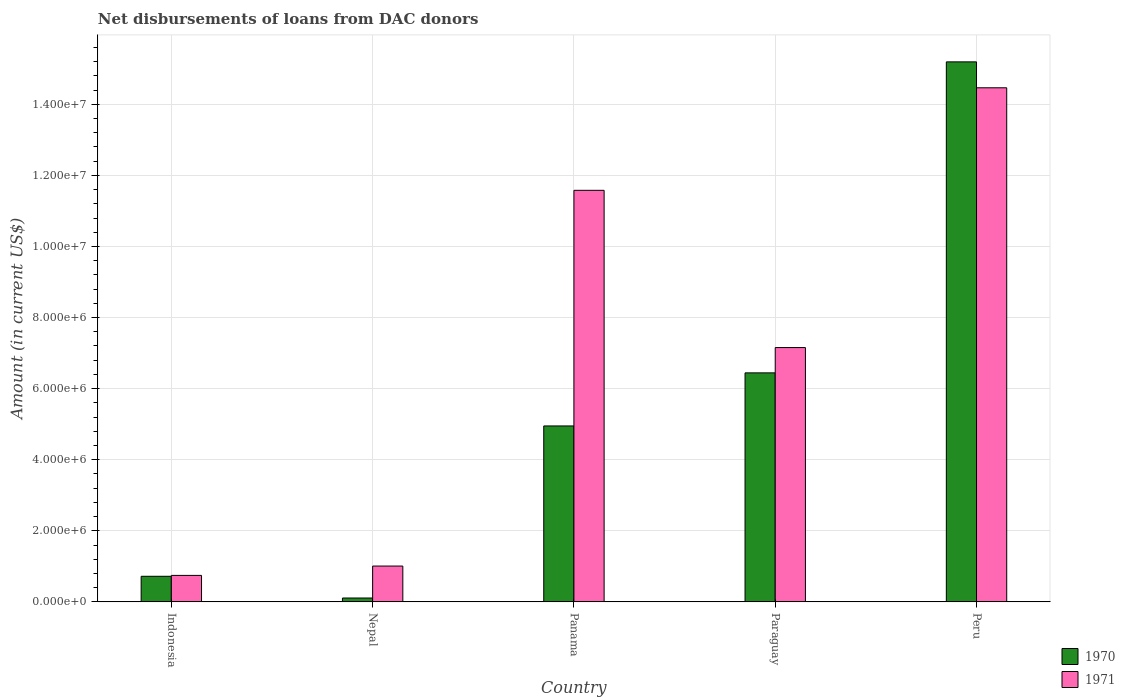How many different coloured bars are there?
Your response must be concise. 2. How many bars are there on the 1st tick from the left?
Your answer should be very brief. 2. How many bars are there on the 3rd tick from the right?
Your response must be concise. 2. What is the label of the 5th group of bars from the left?
Provide a succinct answer. Peru. What is the amount of loans disbursed in 1971 in Peru?
Your answer should be very brief. 1.45e+07. Across all countries, what is the maximum amount of loans disbursed in 1971?
Offer a terse response. 1.45e+07. Across all countries, what is the minimum amount of loans disbursed in 1970?
Your response must be concise. 1.09e+05. In which country was the amount of loans disbursed in 1971 maximum?
Make the answer very short. Peru. In which country was the amount of loans disbursed in 1970 minimum?
Keep it short and to the point. Nepal. What is the total amount of loans disbursed in 1970 in the graph?
Keep it short and to the point. 2.74e+07. What is the difference between the amount of loans disbursed in 1971 in Indonesia and that in Nepal?
Provide a succinct answer. -2.63e+05. What is the difference between the amount of loans disbursed in 1971 in Nepal and the amount of loans disbursed in 1970 in Paraguay?
Keep it short and to the point. -5.44e+06. What is the average amount of loans disbursed in 1970 per country?
Ensure brevity in your answer.  5.48e+06. What is the difference between the amount of loans disbursed of/in 1970 and amount of loans disbursed of/in 1971 in Paraguay?
Your answer should be compact. -7.12e+05. What is the ratio of the amount of loans disbursed in 1971 in Indonesia to that in Paraguay?
Your answer should be very brief. 0.1. Is the amount of loans disbursed in 1971 in Panama less than that in Paraguay?
Give a very brief answer. No. Is the difference between the amount of loans disbursed in 1970 in Nepal and Paraguay greater than the difference between the amount of loans disbursed in 1971 in Nepal and Paraguay?
Your response must be concise. No. What is the difference between the highest and the second highest amount of loans disbursed in 1970?
Provide a short and direct response. 1.02e+07. What is the difference between the highest and the lowest amount of loans disbursed in 1971?
Ensure brevity in your answer.  1.37e+07. In how many countries, is the amount of loans disbursed in 1971 greater than the average amount of loans disbursed in 1971 taken over all countries?
Offer a very short reply. 3. What does the 1st bar from the right in Nepal represents?
Offer a terse response. 1971. How many countries are there in the graph?
Make the answer very short. 5. Are the values on the major ticks of Y-axis written in scientific E-notation?
Your answer should be compact. Yes. Does the graph contain any zero values?
Provide a short and direct response. No. Does the graph contain grids?
Your response must be concise. Yes. Where does the legend appear in the graph?
Provide a succinct answer. Bottom right. How many legend labels are there?
Your answer should be very brief. 2. What is the title of the graph?
Your answer should be very brief. Net disbursements of loans from DAC donors. Does "2005" appear as one of the legend labels in the graph?
Offer a very short reply. No. What is the label or title of the X-axis?
Your answer should be very brief. Country. What is the label or title of the Y-axis?
Make the answer very short. Amount (in current US$). What is the Amount (in current US$) of 1970 in Indonesia?
Keep it short and to the point. 7.20e+05. What is the Amount (in current US$) of 1971 in Indonesia?
Your answer should be compact. 7.45e+05. What is the Amount (in current US$) of 1970 in Nepal?
Give a very brief answer. 1.09e+05. What is the Amount (in current US$) of 1971 in Nepal?
Make the answer very short. 1.01e+06. What is the Amount (in current US$) of 1970 in Panama?
Offer a terse response. 4.95e+06. What is the Amount (in current US$) in 1971 in Panama?
Offer a very short reply. 1.16e+07. What is the Amount (in current US$) in 1970 in Paraguay?
Offer a very short reply. 6.44e+06. What is the Amount (in current US$) of 1971 in Paraguay?
Make the answer very short. 7.16e+06. What is the Amount (in current US$) of 1970 in Peru?
Offer a very short reply. 1.52e+07. What is the Amount (in current US$) of 1971 in Peru?
Offer a very short reply. 1.45e+07. Across all countries, what is the maximum Amount (in current US$) of 1970?
Offer a terse response. 1.52e+07. Across all countries, what is the maximum Amount (in current US$) in 1971?
Your response must be concise. 1.45e+07. Across all countries, what is the minimum Amount (in current US$) of 1970?
Your response must be concise. 1.09e+05. Across all countries, what is the minimum Amount (in current US$) in 1971?
Your response must be concise. 7.45e+05. What is the total Amount (in current US$) of 1970 in the graph?
Your response must be concise. 2.74e+07. What is the total Amount (in current US$) of 1971 in the graph?
Give a very brief answer. 3.50e+07. What is the difference between the Amount (in current US$) in 1970 in Indonesia and that in Nepal?
Offer a terse response. 6.11e+05. What is the difference between the Amount (in current US$) of 1971 in Indonesia and that in Nepal?
Make the answer very short. -2.63e+05. What is the difference between the Amount (in current US$) in 1970 in Indonesia and that in Panama?
Make the answer very short. -4.23e+06. What is the difference between the Amount (in current US$) of 1971 in Indonesia and that in Panama?
Give a very brief answer. -1.08e+07. What is the difference between the Amount (in current US$) of 1970 in Indonesia and that in Paraguay?
Provide a succinct answer. -5.72e+06. What is the difference between the Amount (in current US$) in 1971 in Indonesia and that in Paraguay?
Ensure brevity in your answer.  -6.41e+06. What is the difference between the Amount (in current US$) in 1970 in Indonesia and that in Peru?
Your answer should be compact. -1.45e+07. What is the difference between the Amount (in current US$) in 1971 in Indonesia and that in Peru?
Your answer should be compact. -1.37e+07. What is the difference between the Amount (in current US$) in 1970 in Nepal and that in Panama?
Offer a terse response. -4.84e+06. What is the difference between the Amount (in current US$) of 1971 in Nepal and that in Panama?
Give a very brief answer. -1.06e+07. What is the difference between the Amount (in current US$) of 1970 in Nepal and that in Paraguay?
Give a very brief answer. -6.33e+06. What is the difference between the Amount (in current US$) in 1971 in Nepal and that in Paraguay?
Your answer should be compact. -6.15e+06. What is the difference between the Amount (in current US$) of 1970 in Nepal and that in Peru?
Your answer should be very brief. -1.51e+07. What is the difference between the Amount (in current US$) of 1971 in Nepal and that in Peru?
Your answer should be compact. -1.35e+07. What is the difference between the Amount (in current US$) of 1970 in Panama and that in Paraguay?
Provide a succinct answer. -1.49e+06. What is the difference between the Amount (in current US$) in 1971 in Panama and that in Paraguay?
Your answer should be very brief. 4.42e+06. What is the difference between the Amount (in current US$) of 1970 in Panama and that in Peru?
Offer a very short reply. -1.02e+07. What is the difference between the Amount (in current US$) of 1971 in Panama and that in Peru?
Offer a terse response. -2.88e+06. What is the difference between the Amount (in current US$) of 1970 in Paraguay and that in Peru?
Your response must be concise. -8.75e+06. What is the difference between the Amount (in current US$) of 1971 in Paraguay and that in Peru?
Provide a short and direct response. -7.31e+06. What is the difference between the Amount (in current US$) in 1970 in Indonesia and the Amount (in current US$) in 1971 in Nepal?
Give a very brief answer. -2.88e+05. What is the difference between the Amount (in current US$) of 1970 in Indonesia and the Amount (in current US$) of 1971 in Panama?
Your answer should be compact. -1.09e+07. What is the difference between the Amount (in current US$) of 1970 in Indonesia and the Amount (in current US$) of 1971 in Paraguay?
Your response must be concise. -6.44e+06. What is the difference between the Amount (in current US$) in 1970 in Indonesia and the Amount (in current US$) in 1971 in Peru?
Your answer should be very brief. -1.37e+07. What is the difference between the Amount (in current US$) of 1970 in Nepal and the Amount (in current US$) of 1971 in Panama?
Your response must be concise. -1.15e+07. What is the difference between the Amount (in current US$) in 1970 in Nepal and the Amount (in current US$) in 1971 in Paraguay?
Ensure brevity in your answer.  -7.05e+06. What is the difference between the Amount (in current US$) in 1970 in Nepal and the Amount (in current US$) in 1971 in Peru?
Make the answer very short. -1.44e+07. What is the difference between the Amount (in current US$) in 1970 in Panama and the Amount (in current US$) in 1971 in Paraguay?
Your answer should be very brief. -2.20e+06. What is the difference between the Amount (in current US$) of 1970 in Panama and the Amount (in current US$) of 1971 in Peru?
Keep it short and to the point. -9.51e+06. What is the difference between the Amount (in current US$) in 1970 in Paraguay and the Amount (in current US$) in 1971 in Peru?
Your response must be concise. -8.02e+06. What is the average Amount (in current US$) in 1970 per country?
Your answer should be very brief. 5.48e+06. What is the average Amount (in current US$) of 1971 per country?
Keep it short and to the point. 6.99e+06. What is the difference between the Amount (in current US$) in 1970 and Amount (in current US$) in 1971 in Indonesia?
Keep it short and to the point. -2.50e+04. What is the difference between the Amount (in current US$) in 1970 and Amount (in current US$) in 1971 in Nepal?
Provide a succinct answer. -8.99e+05. What is the difference between the Amount (in current US$) of 1970 and Amount (in current US$) of 1971 in Panama?
Provide a short and direct response. -6.63e+06. What is the difference between the Amount (in current US$) of 1970 and Amount (in current US$) of 1971 in Paraguay?
Ensure brevity in your answer.  -7.12e+05. What is the difference between the Amount (in current US$) of 1970 and Amount (in current US$) of 1971 in Peru?
Provide a succinct answer. 7.29e+05. What is the ratio of the Amount (in current US$) in 1970 in Indonesia to that in Nepal?
Make the answer very short. 6.61. What is the ratio of the Amount (in current US$) of 1971 in Indonesia to that in Nepal?
Your answer should be compact. 0.74. What is the ratio of the Amount (in current US$) of 1970 in Indonesia to that in Panama?
Provide a succinct answer. 0.15. What is the ratio of the Amount (in current US$) of 1971 in Indonesia to that in Panama?
Your answer should be compact. 0.06. What is the ratio of the Amount (in current US$) of 1970 in Indonesia to that in Paraguay?
Give a very brief answer. 0.11. What is the ratio of the Amount (in current US$) in 1971 in Indonesia to that in Paraguay?
Offer a very short reply. 0.1. What is the ratio of the Amount (in current US$) in 1970 in Indonesia to that in Peru?
Your answer should be compact. 0.05. What is the ratio of the Amount (in current US$) of 1971 in Indonesia to that in Peru?
Keep it short and to the point. 0.05. What is the ratio of the Amount (in current US$) in 1970 in Nepal to that in Panama?
Keep it short and to the point. 0.02. What is the ratio of the Amount (in current US$) in 1971 in Nepal to that in Panama?
Offer a terse response. 0.09. What is the ratio of the Amount (in current US$) in 1970 in Nepal to that in Paraguay?
Your answer should be compact. 0.02. What is the ratio of the Amount (in current US$) of 1971 in Nepal to that in Paraguay?
Provide a short and direct response. 0.14. What is the ratio of the Amount (in current US$) of 1970 in Nepal to that in Peru?
Ensure brevity in your answer.  0.01. What is the ratio of the Amount (in current US$) of 1971 in Nepal to that in Peru?
Provide a succinct answer. 0.07. What is the ratio of the Amount (in current US$) in 1970 in Panama to that in Paraguay?
Provide a succinct answer. 0.77. What is the ratio of the Amount (in current US$) in 1971 in Panama to that in Paraguay?
Provide a succinct answer. 1.62. What is the ratio of the Amount (in current US$) of 1970 in Panama to that in Peru?
Provide a succinct answer. 0.33. What is the ratio of the Amount (in current US$) of 1971 in Panama to that in Peru?
Offer a terse response. 0.8. What is the ratio of the Amount (in current US$) of 1970 in Paraguay to that in Peru?
Provide a succinct answer. 0.42. What is the ratio of the Amount (in current US$) of 1971 in Paraguay to that in Peru?
Ensure brevity in your answer.  0.49. What is the difference between the highest and the second highest Amount (in current US$) of 1970?
Offer a very short reply. 8.75e+06. What is the difference between the highest and the second highest Amount (in current US$) of 1971?
Ensure brevity in your answer.  2.88e+06. What is the difference between the highest and the lowest Amount (in current US$) of 1970?
Make the answer very short. 1.51e+07. What is the difference between the highest and the lowest Amount (in current US$) in 1971?
Your answer should be very brief. 1.37e+07. 